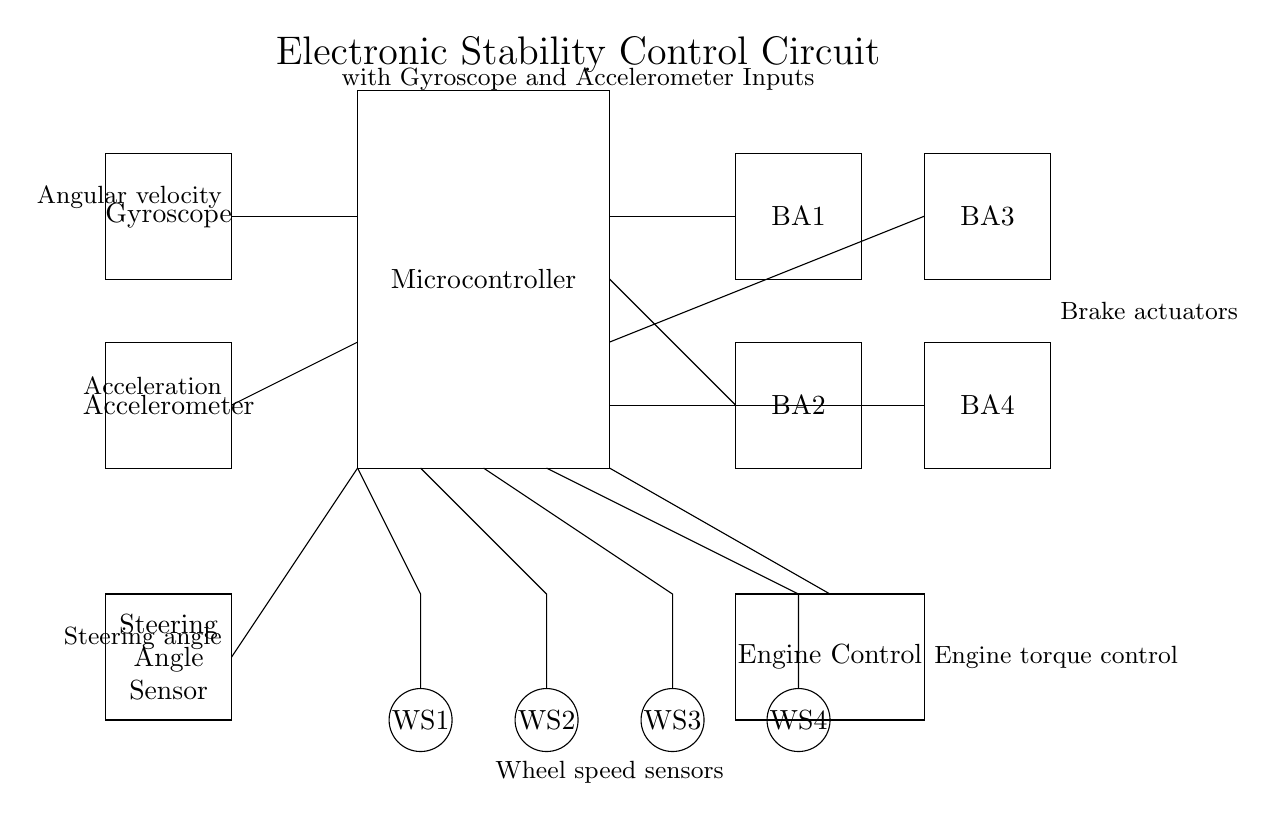What are the main components of this circuit? The main components include a Microcontroller, Gyroscope, Accelerometer, Steering Angle Sensor, Wheel Speed Sensors, Brake Actuators, and Engine Control. Each component plays a critical role in the electronic stability control system, contributing to the overall vehicle dynamics and stability.
Answer: Microcontroller, Gyroscope, Accelerometer, Steering Angle Sensor, Wheel Speed Sensors, Brake Actuators, Engine Control What is the function of the gyroscope in this circuit? The gyroscope measures angular velocity, which helps in determining the orientation and stability of the vehicle. This information is crucial for the microcontroller to make real-time adjustments in vehicle dynamics to maintain stability.
Answer: Angular velocity measurement How many wheel speed sensors are depicted in the circuit? There are four wheel speed sensors shown in the circuit, labeled WS1, WS2, WS3, and WS4. Each sensor monitors the rotational speed of the respective wheel to assess vehicle behavior during dynamic maneuvers.
Answer: Four What type of control signals can the brake actuators receive from the microcontroller? The brake actuators can receive control signals for application and release of braking force depending on the inputs from sensors. The microcontroller processes data from the gyroscope, accelerometer, and wheel speed sensors to control the brake actuators for stability control.
Answer: Braking force control How do the inputs from the accelerometer and gyroscope influence the engine control? The accelerometer provides acceleration data while the gyroscope provides angular velocity data. Together, they inform the microcontroller about the vehicle's dynamics, allowing it to adjust the engine torque in real time, thus enhancing stability and handling. The engine control system uses this information to optimize engine performance under varying conditions.
Answer: Engine torque adjustment 